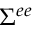<formula> <loc_0><loc_0><loc_500><loc_500>\Sigma ^ { e e }</formula> 